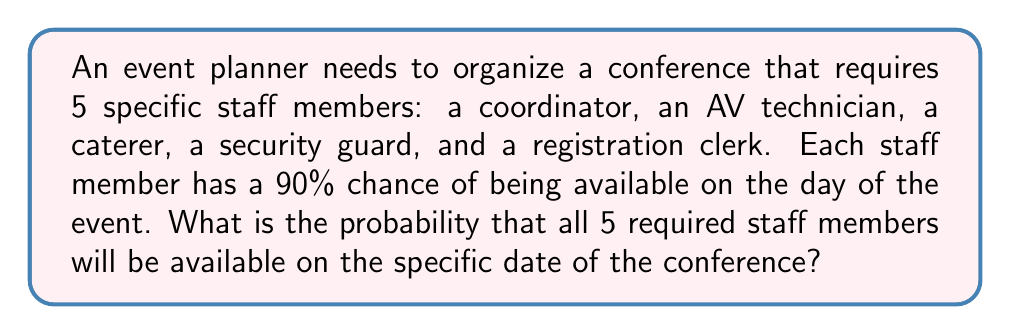Show me your answer to this math problem. Let's approach this step-by-step:

1) First, we need to understand that for all staff members to be available, each individual must be available independently.

2) The probability of each staff member being available is 90% or 0.9.

3) To find the probability of all 5 being available, we need to multiply the individual probabilities:

   $P(\text{all available}) = P(\text{coordinator}) \times P(\text{AV tech}) \times P(\text{caterer}) \times P(\text{security}) \times P(\text{clerk})$

4) Since each probability is 0.9, we can simplify this to:

   $P(\text{all available}) = 0.9 \times 0.9 \times 0.9 \times 0.9 \times 0.9$

5) This is equivalent to:

   $P(\text{all available}) = 0.9^5$

6) Calculate:

   $0.9^5 = 0.59049$

7) Convert to a percentage:

   $0.59049 \times 100\% = 59.049\%$

Therefore, the probability that all 5 required staff members will be available on the specific date is approximately 59.049%.
Answer: $59.049\%$ 